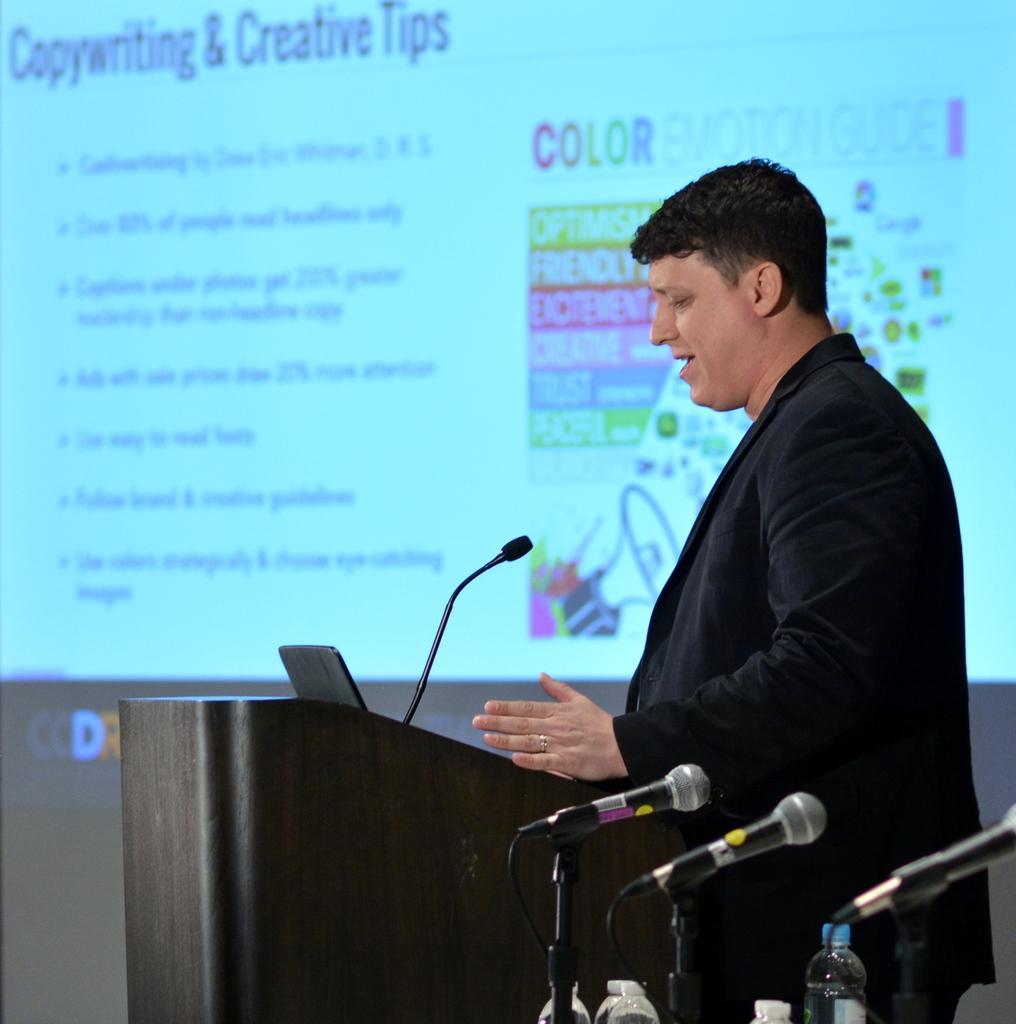In one or two sentences, can you explain what this image depicts? In this picture there is a person standing and talking and we can see microphone and black object on the podium. We can see bottles and microphones. In the background of the image we can see screen. 